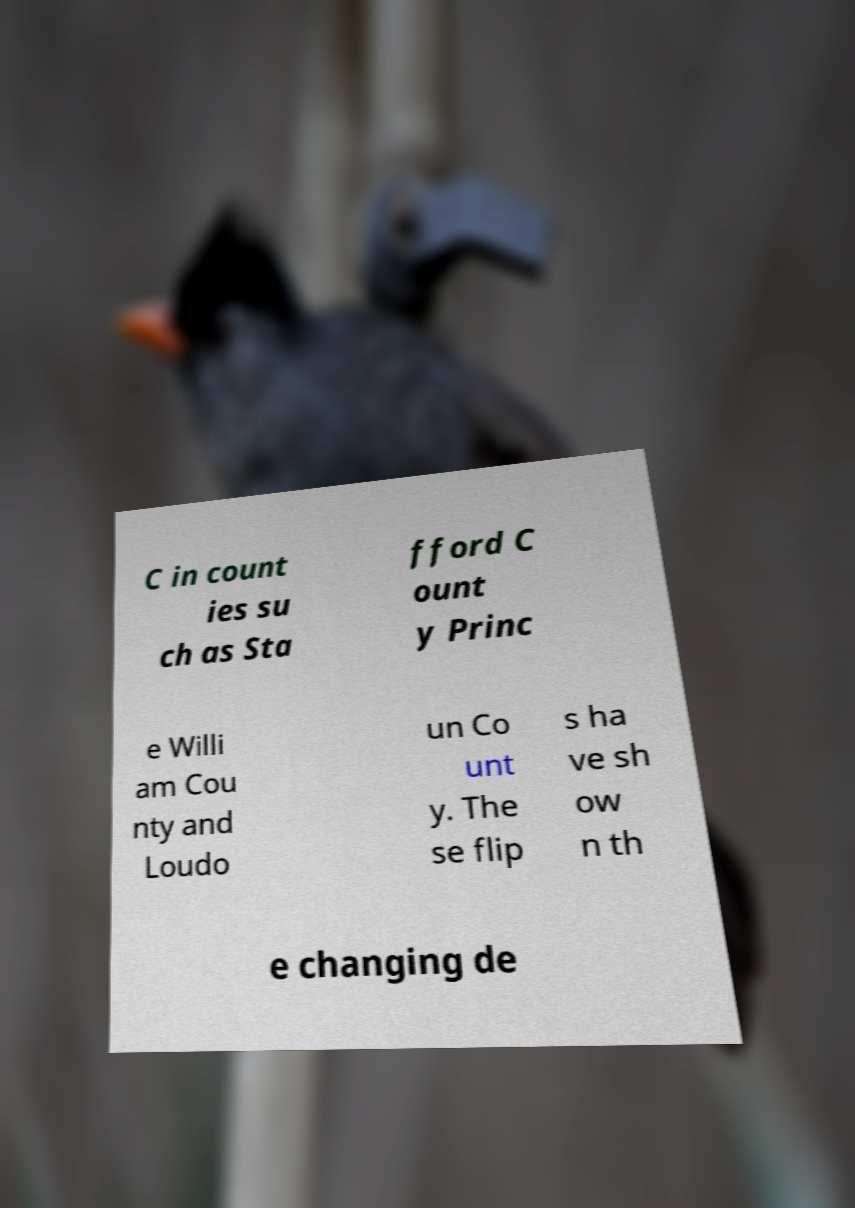There's text embedded in this image that I need extracted. Can you transcribe it verbatim? C in count ies su ch as Sta fford C ount y Princ e Willi am Cou nty and Loudo un Co unt y. The se flip s ha ve sh ow n th e changing de 